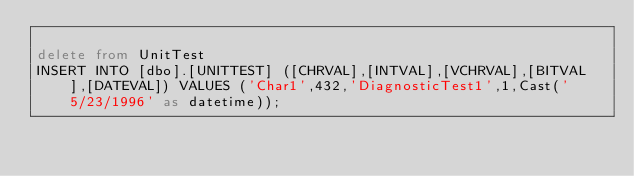<code> <loc_0><loc_0><loc_500><loc_500><_SQL_>
delete from UnitTest
INSERT INTO [dbo].[UNITTEST] ([CHRVAL],[INTVAL],[VCHRVAL],[BITVAL],[DATEVAL]) VALUES ('Char1',432,'DiagnosticTest1',1,Cast('5/23/1996' as datetime));


</code> 